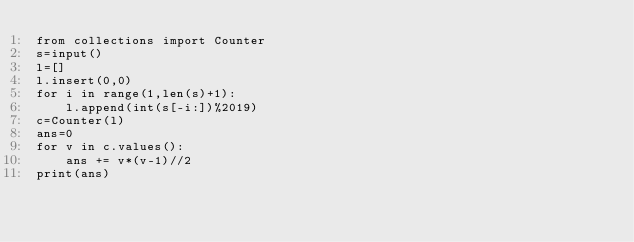Convert code to text. <code><loc_0><loc_0><loc_500><loc_500><_Python_>from collections import Counter
s=input()
l=[]
l.insert(0,0)
for i in range(1,len(s)+1):
    l.append(int(s[-i:])%2019)
c=Counter(l)
ans=0
for v in c.values():
    ans += v*(v-1)//2
print(ans)</code> 